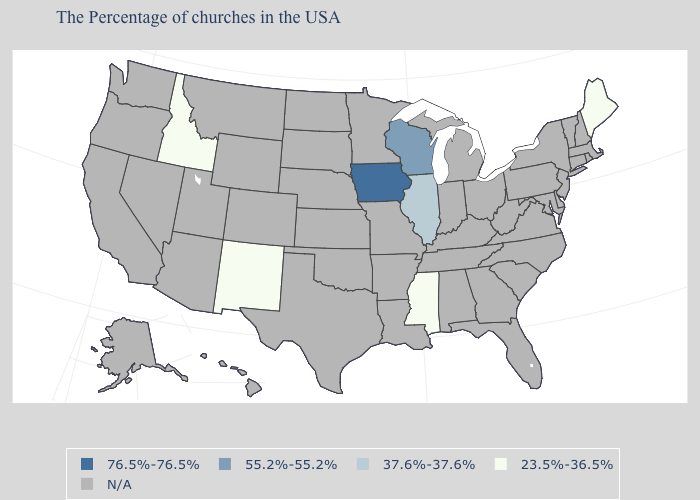Name the states that have a value in the range 55.2%-55.2%?
Short answer required. Wisconsin. Name the states that have a value in the range 76.5%-76.5%?
Be succinct. Iowa. How many symbols are there in the legend?
Quick response, please. 5. Does the map have missing data?
Concise answer only. Yes. What is the lowest value in the USA?
Give a very brief answer. 23.5%-36.5%. Name the states that have a value in the range N/A?
Quick response, please. Massachusetts, Rhode Island, New Hampshire, Vermont, Connecticut, New York, New Jersey, Delaware, Maryland, Pennsylvania, Virginia, North Carolina, South Carolina, West Virginia, Ohio, Florida, Georgia, Michigan, Kentucky, Indiana, Alabama, Tennessee, Louisiana, Missouri, Arkansas, Minnesota, Kansas, Nebraska, Oklahoma, Texas, South Dakota, North Dakota, Wyoming, Colorado, Utah, Montana, Arizona, Nevada, California, Washington, Oregon, Alaska, Hawaii. What is the lowest value in the USA?
Answer briefly. 23.5%-36.5%. Name the states that have a value in the range 76.5%-76.5%?
Be succinct. Iowa. Does Idaho have the highest value in the USA?
Answer briefly. No. What is the lowest value in states that border Wyoming?
Answer briefly. 23.5%-36.5%. What is the highest value in the USA?
Quick response, please. 76.5%-76.5%. What is the value of New Jersey?
Answer briefly. N/A. Name the states that have a value in the range 76.5%-76.5%?
Answer briefly. Iowa. 